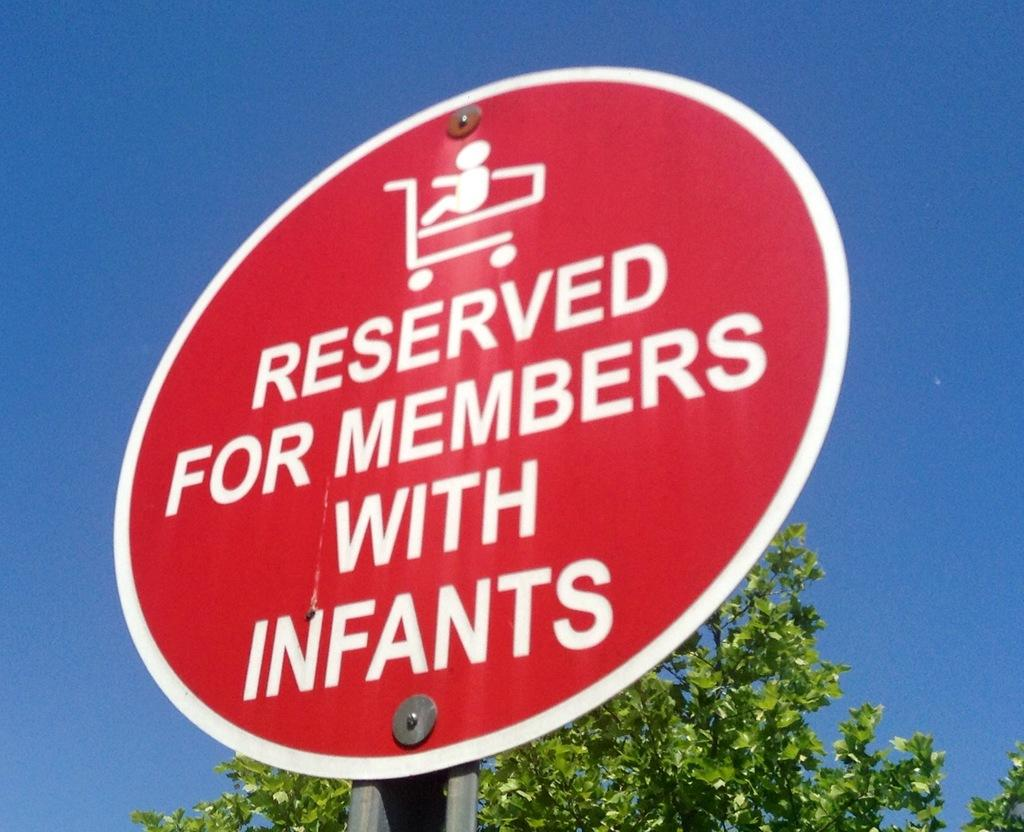<image>
Create a compact narrative representing the image presented. A circular sign warns that an area is for people with infants. 